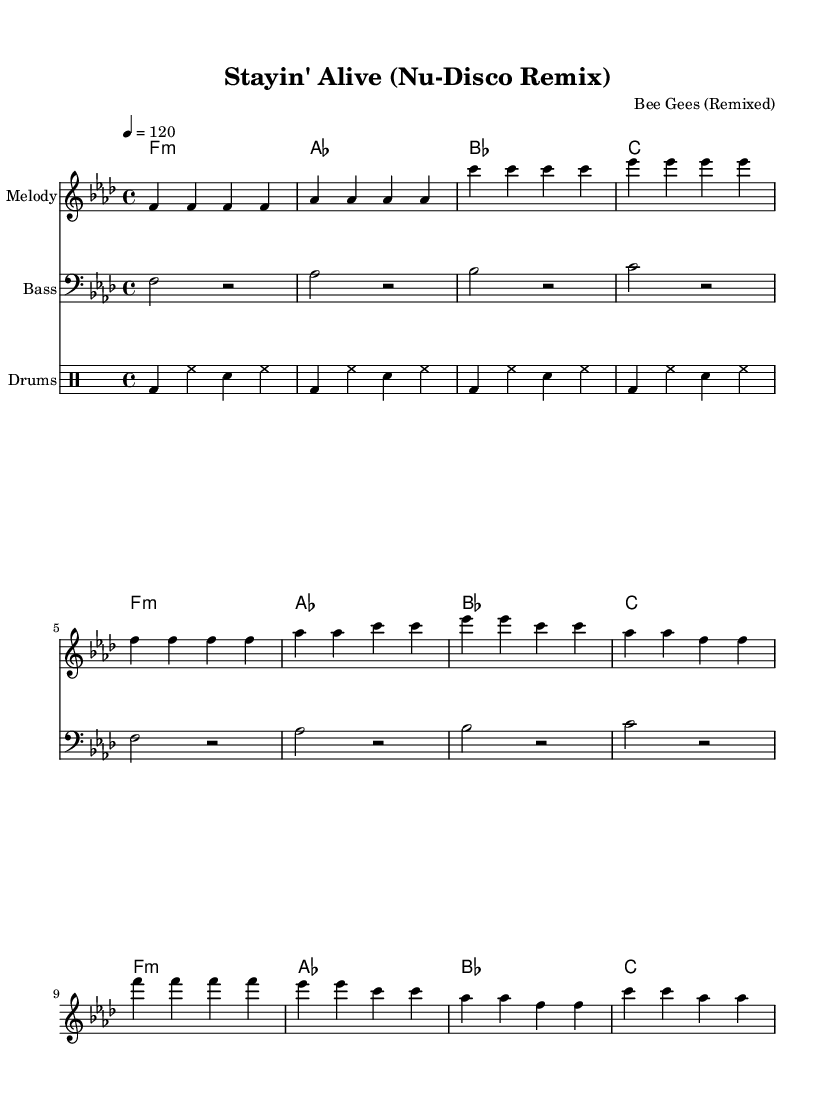What is the key signature of this music? The key signature is identified by the flats or sharps present at the beginning of the staff. In this case, F minor has four flats: B flat, E flat, A flat, and D flat.
Answer: F minor What is the time signature of this music? The time signature is located at the beginning of the staff and is indicated as 4/4. This means there are four beats in each measure and the quarter note gets one beat.
Answer: 4/4 What is the tempo of this piece? The tempo is indicated at the beginning of the score with a marking that states "4 = 120," which specifies the metronome marking of 120 beats per minute.
Answer: 120 How many measures are in the chorus section? To find out how many measures are in the chorus, we should count the number of measures labeled in that section. There are four measures in the chorus as represented in the staff.
Answer: 4 What type of instrument plays the melody? In the score, the staff that shows the melody is labeled "Melody," and it is written in the treble clef, which is typically associated with instruments like the violin or flute.
Answer: Melody What is the first chord in the harmony section? The harmony section begins with a chord symbol that indicates F minor, which is shown as "f:m" at the start of the score.
Answer: F minor What rhythmic pattern do the drums follow? The drumming notation indicates a consistent rhythm of bass drums and hi-hats, playing in a repeating pattern through the measures. The specific pattern is bass drums on beats one and three, with hi-hats on the off-beats.
Answer: Bass-Hi-Hat pattern 